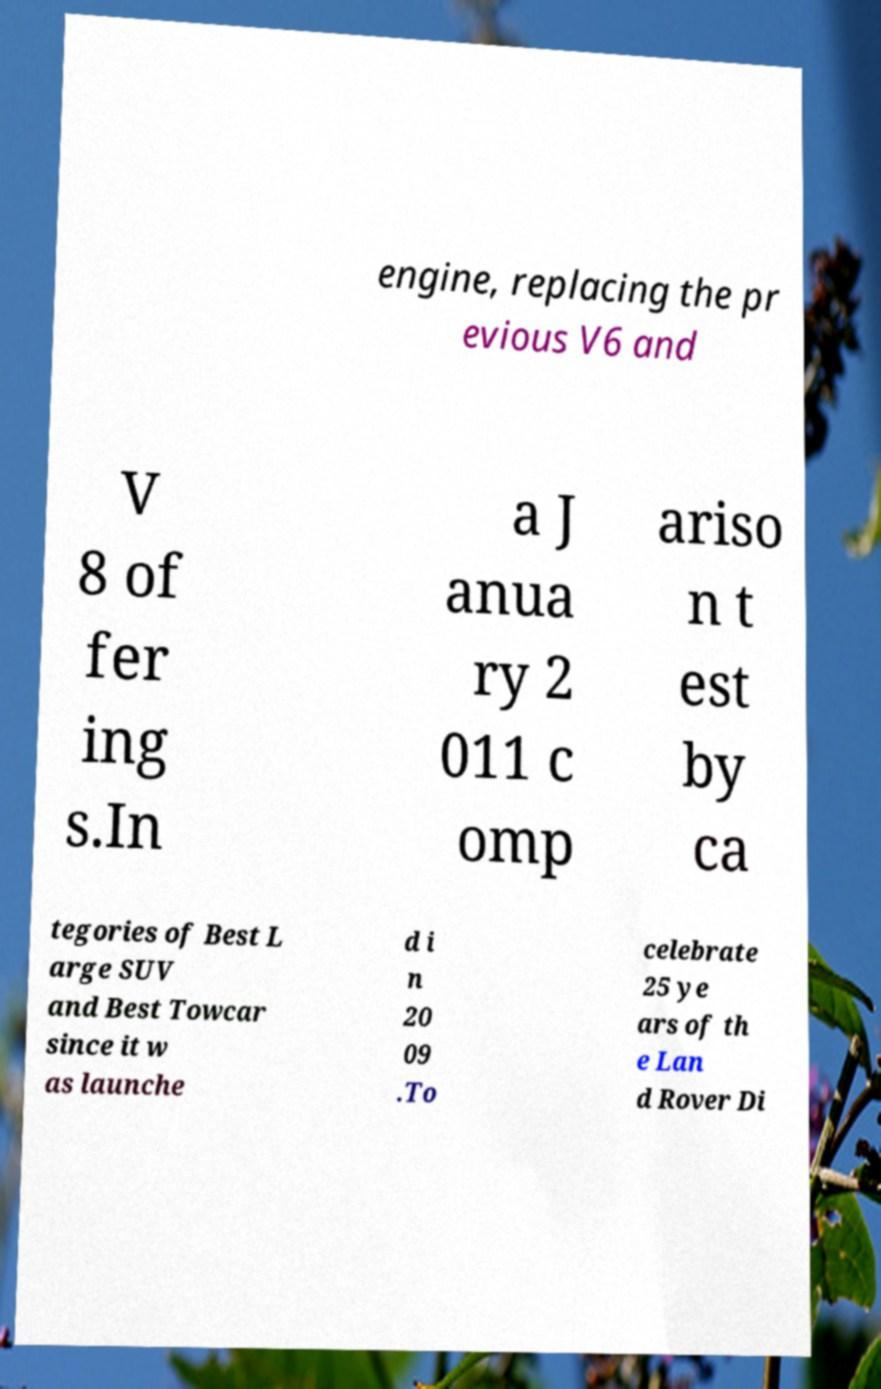Could you extract and type out the text from this image? engine, replacing the pr evious V6 and V 8 of fer ing s.In a J anua ry 2 011 c omp ariso n t est by ca tegories of Best L arge SUV and Best Towcar since it w as launche d i n 20 09 .To celebrate 25 ye ars of th e Lan d Rover Di 